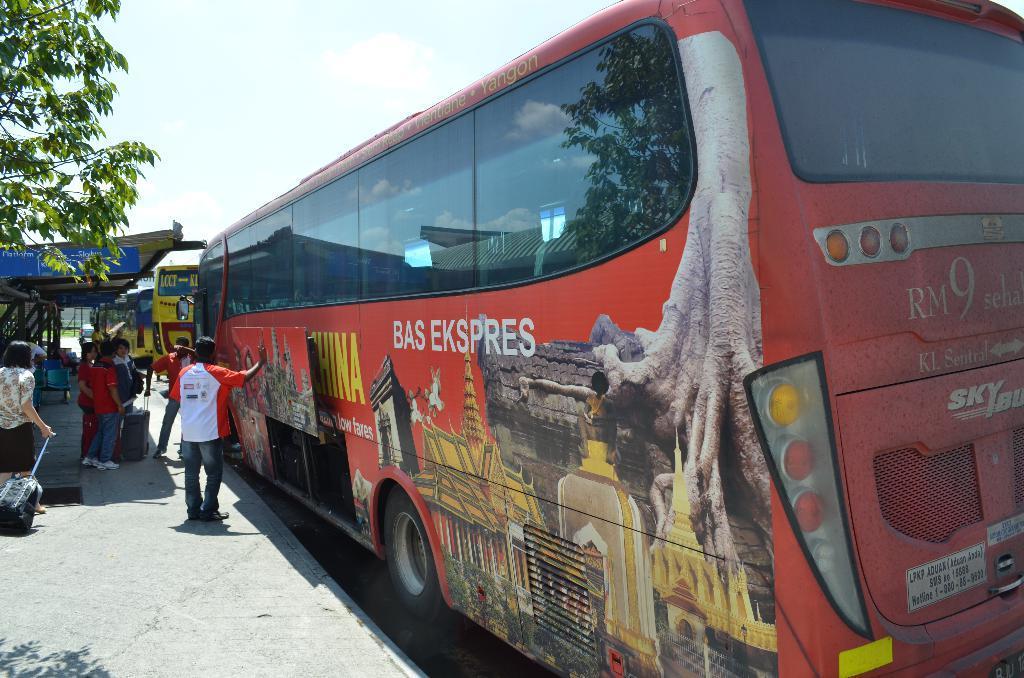Can you describe this image briefly? This image is taken outdoors. At the top of the image there is a sky with clouds. At the bottom of the image there is a road. On the left side of the image there is a tree and there is a bus stop. A few people are sitting on the chairs and a few are standing on the road and they are holding luggage bags in their hands. In the middle of the image two buses are parked on the road. 